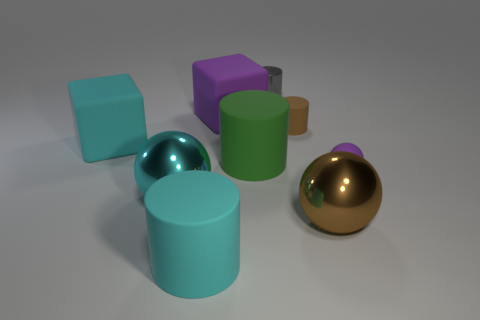There is another block that is the same size as the cyan rubber block; what is its color?
Make the answer very short. Purple. Is the shape of the shiny object to the left of the gray metal cylinder the same as  the small purple thing?
Ensure brevity in your answer.  Yes. There is a large matte cube that is behind the cyan thing left of the large metal sphere that is on the left side of the tiny gray metal object; what is its color?
Your response must be concise. Purple. Is there a big cyan ball?
Provide a succinct answer. Yes. How many other objects are there of the same size as the cyan matte cylinder?
Offer a terse response. 5. There is a small ball; is it the same color as the big rubber cube right of the cyan shiny thing?
Your answer should be very brief. Yes. What number of things are either tiny metallic things or big cyan cubes?
Give a very brief answer. 2. Is there any other thing of the same color as the tiny metal object?
Your answer should be very brief. No. Is the green cylinder made of the same material as the block left of the large cyan matte cylinder?
Offer a very short reply. Yes. There is a brown object in front of the purple rubber object that is to the right of the shiny cylinder; what is its shape?
Provide a short and direct response. Sphere. 